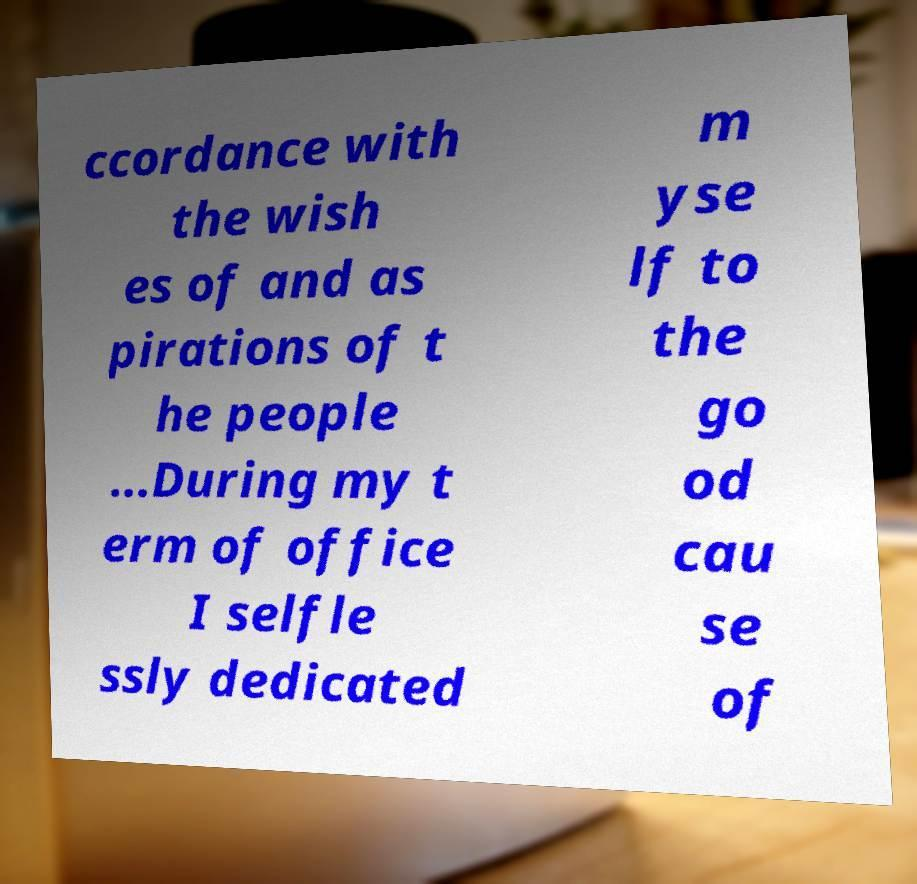Please identify and transcribe the text found in this image. ccordance with the wish es of and as pirations of t he people ...During my t erm of office I selfle ssly dedicated m yse lf to the go od cau se of 